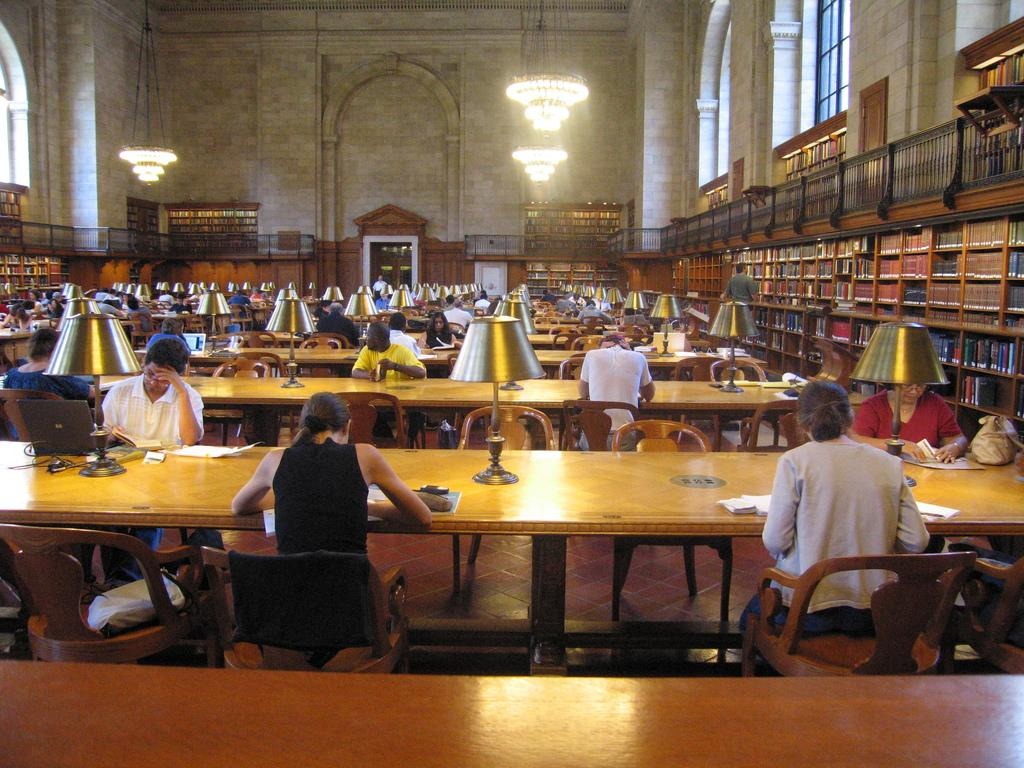What are the people in the image doing? The people in the image are sitting on chairs. What can be seen on the table in the image? There is a lamp, a book, and a laptop on the table in the image. Where is the book rack located in the image? The book rack is on the right side of the image. What type of bird can be seen in the wilderness in the image? There is no bird or wilderness present in the image. Can you read the note that is on the table in the image? There is no note present on the table in the image. 